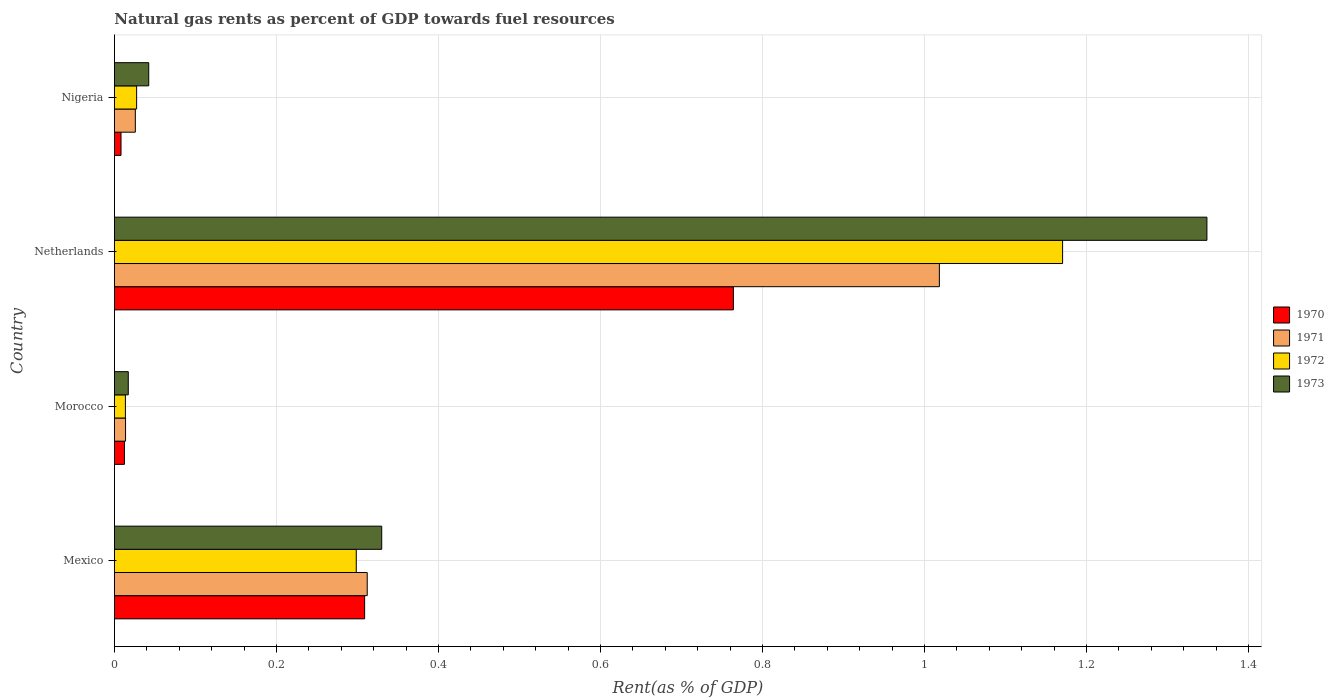Are the number of bars per tick equal to the number of legend labels?
Give a very brief answer. Yes. Are the number of bars on each tick of the Y-axis equal?
Keep it short and to the point. Yes. What is the label of the 3rd group of bars from the top?
Make the answer very short. Morocco. What is the matural gas rent in 1973 in Netherlands?
Provide a succinct answer. 1.35. Across all countries, what is the maximum matural gas rent in 1972?
Offer a very short reply. 1.17. Across all countries, what is the minimum matural gas rent in 1971?
Your answer should be very brief. 0.01. In which country was the matural gas rent in 1973 maximum?
Your answer should be very brief. Netherlands. In which country was the matural gas rent in 1972 minimum?
Offer a terse response. Morocco. What is the total matural gas rent in 1972 in the graph?
Ensure brevity in your answer.  1.51. What is the difference between the matural gas rent in 1970 in Netherlands and that in Nigeria?
Keep it short and to the point. 0.76. What is the difference between the matural gas rent in 1973 in Nigeria and the matural gas rent in 1970 in Mexico?
Your response must be concise. -0.27. What is the average matural gas rent in 1970 per country?
Provide a short and direct response. 0.27. What is the difference between the matural gas rent in 1972 and matural gas rent in 1971 in Mexico?
Ensure brevity in your answer.  -0.01. What is the ratio of the matural gas rent in 1970 in Morocco to that in Nigeria?
Keep it short and to the point. 1.52. Is the matural gas rent in 1973 in Morocco less than that in Nigeria?
Your response must be concise. Yes. What is the difference between the highest and the second highest matural gas rent in 1972?
Keep it short and to the point. 0.87. What is the difference between the highest and the lowest matural gas rent in 1970?
Give a very brief answer. 0.76. In how many countries, is the matural gas rent in 1972 greater than the average matural gas rent in 1972 taken over all countries?
Give a very brief answer. 1. Is it the case that in every country, the sum of the matural gas rent in 1973 and matural gas rent in 1970 is greater than the sum of matural gas rent in 1971 and matural gas rent in 1972?
Your answer should be very brief. No. What does the 3rd bar from the top in Nigeria represents?
Offer a terse response. 1971. Are all the bars in the graph horizontal?
Your response must be concise. Yes. How many countries are there in the graph?
Your response must be concise. 4. Where does the legend appear in the graph?
Your answer should be very brief. Center right. What is the title of the graph?
Your answer should be very brief. Natural gas rents as percent of GDP towards fuel resources. What is the label or title of the X-axis?
Your answer should be compact. Rent(as % of GDP). What is the label or title of the Y-axis?
Offer a very short reply. Country. What is the Rent(as % of GDP) of 1970 in Mexico?
Offer a terse response. 0.31. What is the Rent(as % of GDP) in 1971 in Mexico?
Keep it short and to the point. 0.31. What is the Rent(as % of GDP) of 1972 in Mexico?
Make the answer very short. 0.3. What is the Rent(as % of GDP) of 1973 in Mexico?
Ensure brevity in your answer.  0.33. What is the Rent(as % of GDP) in 1970 in Morocco?
Offer a terse response. 0.01. What is the Rent(as % of GDP) of 1971 in Morocco?
Offer a very short reply. 0.01. What is the Rent(as % of GDP) in 1972 in Morocco?
Your answer should be compact. 0.01. What is the Rent(as % of GDP) of 1973 in Morocco?
Offer a terse response. 0.02. What is the Rent(as % of GDP) in 1970 in Netherlands?
Your response must be concise. 0.76. What is the Rent(as % of GDP) in 1971 in Netherlands?
Provide a short and direct response. 1.02. What is the Rent(as % of GDP) of 1972 in Netherlands?
Offer a very short reply. 1.17. What is the Rent(as % of GDP) of 1973 in Netherlands?
Make the answer very short. 1.35. What is the Rent(as % of GDP) in 1970 in Nigeria?
Make the answer very short. 0.01. What is the Rent(as % of GDP) of 1971 in Nigeria?
Offer a terse response. 0.03. What is the Rent(as % of GDP) in 1972 in Nigeria?
Your answer should be very brief. 0.03. What is the Rent(as % of GDP) in 1973 in Nigeria?
Give a very brief answer. 0.04. Across all countries, what is the maximum Rent(as % of GDP) in 1970?
Provide a short and direct response. 0.76. Across all countries, what is the maximum Rent(as % of GDP) of 1971?
Your response must be concise. 1.02. Across all countries, what is the maximum Rent(as % of GDP) of 1972?
Your answer should be compact. 1.17. Across all countries, what is the maximum Rent(as % of GDP) of 1973?
Your answer should be compact. 1.35. Across all countries, what is the minimum Rent(as % of GDP) in 1970?
Your answer should be very brief. 0.01. Across all countries, what is the minimum Rent(as % of GDP) in 1971?
Provide a succinct answer. 0.01. Across all countries, what is the minimum Rent(as % of GDP) of 1972?
Your response must be concise. 0.01. Across all countries, what is the minimum Rent(as % of GDP) of 1973?
Give a very brief answer. 0.02. What is the total Rent(as % of GDP) of 1970 in the graph?
Give a very brief answer. 1.09. What is the total Rent(as % of GDP) of 1971 in the graph?
Give a very brief answer. 1.37. What is the total Rent(as % of GDP) in 1972 in the graph?
Provide a succinct answer. 1.51. What is the total Rent(as % of GDP) in 1973 in the graph?
Your answer should be compact. 1.74. What is the difference between the Rent(as % of GDP) in 1970 in Mexico and that in Morocco?
Provide a succinct answer. 0.3. What is the difference between the Rent(as % of GDP) of 1971 in Mexico and that in Morocco?
Make the answer very short. 0.3. What is the difference between the Rent(as % of GDP) in 1972 in Mexico and that in Morocco?
Provide a short and direct response. 0.28. What is the difference between the Rent(as % of GDP) in 1973 in Mexico and that in Morocco?
Provide a succinct answer. 0.31. What is the difference between the Rent(as % of GDP) in 1970 in Mexico and that in Netherlands?
Your response must be concise. -0.46. What is the difference between the Rent(as % of GDP) of 1971 in Mexico and that in Netherlands?
Your response must be concise. -0.71. What is the difference between the Rent(as % of GDP) of 1972 in Mexico and that in Netherlands?
Your response must be concise. -0.87. What is the difference between the Rent(as % of GDP) in 1973 in Mexico and that in Netherlands?
Your answer should be compact. -1.02. What is the difference between the Rent(as % of GDP) of 1970 in Mexico and that in Nigeria?
Keep it short and to the point. 0.3. What is the difference between the Rent(as % of GDP) of 1971 in Mexico and that in Nigeria?
Offer a terse response. 0.29. What is the difference between the Rent(as % of GDP) of 1972 in Mexico and that in Nigeria?
Your answer should be compact. 0.27. What is the difference between the Rent(as % of GDP) in 1973 in Mexico and that in Nigeria?
Your answer should be very brief. 0.29. What is the difference between the Rent(as % of GDP) in 1970 in Morocco and that in Netherlands?
Provide a short and direct response. -0.75. What is the difference between the Rent(as % of GDP) of 1971 in Morocco and that in Netherlands?
Keep it short and to the point. -1. What is the difference between the Rent(as % of GDP) in 1972 in Morocco and that in Netherlands?
Your answer should be very brief. -1.16. What is the difference between the Rent(as % of GDP) in 1973 in Morocco and that in Netherlands?
Provide a succinct answer. -1.33. What is the difference between the Rent(as % of GDP) in 1970 in Morocco and that in Nigeria?
Offer a very short reply. 0. What is the difference between the Rent(as % of GDP) of 1971 in Morocco and that in Nigeria?
Offer a terse response. -0.01. What is the difference between the Rent(as % of GDP) of 1972 in Morocco and that in Nigeria?
Your answer should be very brief. -0.01. What is the difference between the Rent(as % of GDP) of 1973 in Morocco and that in Nigeria?
Offer a very short reply. -0.03. What is the difference between the Rent(as % of GDP) of 1970 in Netherlands and that in Nigeria?
Your answer should be compact. 0.76. What is the difference between the Rent(as % of GDP) of 1972 in Netherlands and that in Nigeria?
Offer a terse response. 1.14. What is the difference between the Rent(as % of GDP) of 1973 in Netherlands and that in Nigeria?
Keep it short and to the point. 1.31. What is the difference between the Rent(as % of GDP) in 1970 in Mexico and the Rent(as % of GDP) in 1971 in Morocco?
Provide a succinct answer. 0.3. What is the difference between the Rent(as % of GDP) of 1970 in Mexico and the Rent(as % of GDP) of 1972 in Morocco?
Your answer should be very brief. 0.3. What is the difference between the Rent(as % of GDP) in 1970 in Mexico and the Rent(as % of GDP) in 1973 in Morocco?
Offer a very short reply. 0.29. What is the difference between the Rent(as % of GDP) of 1971 in Mexico and the Rent(as % of GDP) of 1972 in Morocco?
Make the answer very short. 0.3. What is the difference between the Rent(as % of GDP) of 1971 in Mexico and the Rent(as % of GDP) of 1973 in Morocco?
Give a very brief answer. 0.29. What is the difference between the Rent(as % of GDP) of 1972 in Mexico and the Rent(as % of GDP) of 1973 in Morocco?
Your answer should be compact. 0.28. What is the difference between the Rent(as % of GDP) in 1970 in Mexico and the Rent(as % of GDP) in 1971 in Netherlands?
Offer a terse response. -0.71. What is the difference between the Rent(as % of GDP) of 1970 in Mexico and the Rent(as % of GDP) of 1972 in Netherlands?
Make the answer very short. -0.86. What is the difference between the Rent(as % of GDP) in 1970 in Mexico and the Rent(as % of GDP) in 1973 in Netherlands?
Offer a very short reply. -1.04. What is the difference between the Rent(as % of GDP) in 1971 in Mexico and the Rent(as % of GDP) in 1972 in Netherlands?
Offer a very short reply. -0.86. What is the difference between the Rent(as % of GDP) in 1971 in Mexico and the Rent(as % of GDP) in 1973 in Netherlands?
Keep it short and to the point. -1.04. What is the difference between the Rent(as % of GDP) in 1972 in Mexico and the Rent(as % of GDP) in 1973 in Netherlands?
Give a very brief answer. -1.05. What is the difference between the Rent(as % of GDP) of 1970 in Mexico and the Rent(as % of GDP) of 1971 in Nigeria?
Offer a very short reply. 0.28. What is the difference between the Rent(as % of GDP) in 1970 in Mexico and the Rent(as % of GDP) in 1972 in Nigeria?
Make the answer very short. 0.28. What is the difference between the Rent(as % of GDP) of 1970 in Mexico and the Rent(as % of GDP) of 1973 in Nigeria?
Offer a very short reply. 0.27. What is the difference between the Rent(as % of GDP) in 1971 in Mexico and the Rent(as % of GDP) in 1972 in Nigeria?
Give a very brief answer. 0.28. What is the difference between the Rent(as % of GDP) in 1971 in Mexico and the Rent(as % of GDP) in 1973 in Nigeria?
Give a very brief answer. 0.27. What is the difference between the Rent(as % of GDP) of 1972 in Mexico and the Rent(as % of GDP) of 1973 in Nigeria?
Provide a short and direct response. 0.26. What is the difference between the Rent(as % of GDP) in 1970 in Morocco and the Rent(as % of GDP) in 1971 in Netherlands?
Provide a succinct answer. -1.01. What is the difference between the Rent(as % of GDP) of 1970 in Morocco and the Rent(as % of GDP) of 1972 in Netherlands?
Offer a terse response. -1.16. What is the difference between the Rent(as % of GDP) in 1970 in Morocco and the Rent(as % of GDP) in 1973 in Netherlands?
Offer a very short reply. -1.34. What is the difference between the Rent(as % of GDP) in 1971 in Morocco and the Rent(as % of GDP) in 1972 in Netherlands?
Provide a succinct answer. -1.16. What is the difference between the Rent(as % of GDP) in 1971 in Morocco and the Rent(as % of GDP) in 1973 in Netherlands?
Offer a very short reply. -1.33. What is the difference between the Rent(as % of GDP) in 1972 in Morocco and the Rent(as % of GDP) in 1973 in Netherlands?
Offer a very short reply. -1.34. What is the difference between the Rent(as % of GDP) of 1970 in Morocco and the Rent(as % of GDP) of 1971 in Nigeria?
Your answer should be very brief. -0.01. What is the difference between the Rent(as % of GDP) in 1970 in Morocco and the Rent(as % of GDP) in 1972 in Nigeria?
Offer a very short reply. -0.02. What is the difference between the Rent(as % of GDP) in 1970 in Morocco and the Rent(as % of GDP) in 1973 in Nigeria?
Your response must be concise. -0.03. What is the difference between the Rent(as % of GDP) of 1971 in Morocco and the Rent(as % of GDP) of 1972 in Nigeria?
Provide a short and direct response. -0.01. What is the difference between the Rent(as % of GDP) of 1971 in Morocco and the Rent(as % of GDP) of 1973 in Nigeria?
Provide a short and direct response. -0.03. What is the difference between the Rent(as % of GDP) in 1972 in Morocco and the Rent(as % of GDP) in 1973 in Nigeria?
Offer a terse response. -0.03. What is the difference between the Rent(as % of GDP) in 1970 in Netherlands and the Rent(as % of GDP) in 1971 in Nigeria?
Make the answer very short. 0.74. What is the difference between the Rent(as % of GDP) of 1970 in Netherlands and the Rent(as % of GDP) of 1972 in Nigeria?
Offer a terse response. 0.74. What is the difference between the Rent(as % of GDP) in 1970 in Netherlands and the Rent(as % of GDP) in 1973 in Nigeria?
Offer a very short reply. 0.72. What is the difference between the Rent(as % of GDP) of 1972 in Netherlands and the Rent(as % of GDP) of 1973 in Nigeria?
Provide a short and direct response. 1.13. What is the average Rent(as % of GDP) of 1970 per country?
Your answer should be very brief. 0.27. What is the average Rent(as % of GDP) in 1971 per country?
Ensure brevity in your answer.  0.34. What is the average Rent(as % of GDP) of 1972 per country?
Give a very brief answer. 0.38. What is the average Rent(as % of GDP) of 1973 per country?
Make the answer very short. 0.43. What is the difference between the Rent(as % of GDP) in 1970 and Rent(as % of GDP) in 1971 in Mexico?
Your answer should be very brief. -0. What is the difference between the Rent(as % of GDP) of 1970 and Rent(as % of GDP) of 1972 in Mexico?
Ensure brevity in your answer.  0.01. What is the difference between the Rent(as % of GDP) of 1970 and Rent(as % of GDP) of 1973 in Mexico?
Your response must be concise. -0.02. What is the difference between the Rent(as % of GDP) in 1971 and Rent(as % of GDP) in 1972 in Mexico?
Offer a terse response. 0.01. What is the difference between the Rent(as % of GDP) of 1971 and Rent(as % of GDP) of 1973 in Mexico?
Offer a very short reply. -0.02. What is the difference between the Rent(as % of GDP) in 1972 and Rent(as % of GDP) in 1973 in Mexico?
Offer a very short reply. -0.03. What is the difference between the Rent(as % of GDP) in 1970 and Rent(as % of GDP) in 1971 in Morocco?
Ensure brevity in your answer.  -0. What is the difference between the Rent(as % of GDP) of 1970 and Rent(as % of GDP) of 1972 in Morocco?
Ensure brevity in your answer.  -0. What is the difference between the Rent(as % of GDP) of 1970 and Rent(as % of GDP) of 1973 in Morocco?
Your answer should be compact. -0. What is the difference between the Rent(as % of GDP) of 1971 and Rent(as % of GDP) of 1972 in Morocco?
Keep it short and to the point. 0. What is the difference between the Rent(as % of GDP) in 1971 and Rent(as % of GDP) in 1973 in Morocco?
Provide a succinct answer. -0. What is the difference between the Rent(as % of GDP) of 1972 and Rent(as % of GDP) of 1973 in Morocco?
Ensure brevity in your answer.  -0. What is the difference between the Rent(as % of GDP) of 1970 and Rent(as % of GDP) of 1971 in Netherlands?
Give a very brief answer. -0.25. What is the difference between the Rent(as % of GDP) of 1970 and Rent(as % of GDP) of 1972 in Netherlands?
Give a very brief answer. -0.41. What is the difference between the Rent(as % of GDP) in 1970 and Rent(as % of GDP) in 1973 in Netherlands?
Provide a short and direct response. -0.58. What is the difference between the Rent(as % of GDP) in 1971 and Rent(as % of GDP) in 1972 in Netherlands?
Offer a very short reply. -0.15. What is the difference between the Rent(as % of GDP) in 1971 and Rent(as % of GDP) in 1973 in Netherlands?
Offer a very short reply. -0.33. What is the difference between the Rent(as % of GDP) of 1972 and Rent(as % of GDP) of 1973 in Netherlands?
Provide a short and direct response. -0.18. What is the difference between the Rent(as % of GDP) of 1970 and Rent(as % of GDP) of 1971 in Nigeria?
Ensure brevity in your answer.  -0.02. What is the difference between the Rent(as % of GDP) of 1970 and Rent(as % of GDP) of 1972 in Nigeria?
Give a very brief answer. -0.02. What is the difference between the Rent(as % of GDP) in 1970 and Rent(as % of GDP) in 1973 in Nigeria?
Offer a terse response. -0.03. What is the difference between the Rent(as % of GDP) in 1971 and Rent(as % of GDP) in 1972 in Nigeria?
Your answer should be compact. -0. What is the difference between the Rent(as % of GDP) in 1971 and Rent(as % of GDP) in 1973 in Nigeria?
Your answer should be compact. -0.02. What is the difference between the Rent(as % of GDP) in 1972 and Rent(as % of GDP) in 1973 in Nigeria?
Offer a terse response. -0.01. What is the ratio of the Rent(as % of GDP) of 1970 in Mexico to that in Morocco?
Give a very brief answer. 25. What is the ratio of the Rent(as % of GDP) in 1971 in Mexico to that in Morocco?
Make the answer very short. 22.74. What is the ratio of the Rent(as % of GDP) in 1972 in Mexico to that in Morocco?
Keep it short and to the point. 22.04. What is the ratio of the Rent(as % of GDP) of 1973 in Mexico to that in Morocco?
Your answer should be compact. 19.3. What is the ratio of the Rent(as % of GDP) of 1970 in Mexico to that in Netherlands?
Keep it short and to the point. 0.4. What is the ratio of the Rent(as % of GDP) of 1971 in Mexico to that in Netherlands?
Ensure brevity in your answer.  0.31. What is the ratio of the Rent(as % of GDP) in 1972 in Mexico to that in Netherlands?
Offer a terse response. 0.26. What is the ratio of the Rent(as % of GDP) of 1973 in Mexico to that in Netherlands?
Offer a terse response. 0.24. What is the ratio of the Rent(as % of GDP) in 1970 in Mexico to that in Nigeria?
Your response must be concise. 37.97. What is the ratio of the Rent(as % of GDP) in 1971 in Mexico to that in Nigeria?
Ensure brevity in your answer.  12.1. What is the ratio of the Rent(as % of GDP) of 1972 in Mexico to that in Nigeria?
Provide a succinct answer. 10.89. What is the ratio of the Rent(as % of GDP) of 1973 in Mexico to that in Nigeria?
Make the answer very short. 7.79. What is the ratio of the Rent(as % of GDP) in 1970 in Morocco to that in Netherlands?
Provide a short and direct response. 0.02. What is the ratio of the Rent(as % of GDP) in 1971 in Morocco to that in Netherlands?
Your response must be concise. 0.01. What is the ratio of the Rent(as % of GDP) in 1972 in Morocco to that in Netherlands?
Your answer should be compact. 0.01. What is the ratio of the Rent(as % of GDP) in 1973 in Morocco to that in Netherlands?
Give a very brief answer. 0.01. What is the ratio of the Rent(as % of GDP) in 1970 in Morocco to that in Nigeria?
Ensure brevity in your answer.  1.52. What is the ratio of the Rent(as % of GDP) of 1971 in Morocco to that in Nigeria?
Your answer should be compact. 0.53. What is the ratio of the Rent(as % of GDP) in 1972 in Morocco to that in Nigeria?
Keep it short and to the point. 0.49. What is the ratio of the Rent(as % of GDP) in 1973 in Morocco to that in Nigeria?
Make the answer very short. 0.4. What is the ratio of the Rent(as % of GDP) in 1970 in Netherlands to that in Nigeria?
Your answer should be very brief. 93.94. What is the ratio of the Rent(as % of GDP) in 1971 in Netherlands to that in Nigeria?
Give a very brief answer. 39.48. What is the ratio of the Rent(as % of GDP) in 1972 in Netherlands to that in Nigeria?
Give a very brief answer. 42.7. What is the ratio of the Rent(as % of GDP) in 1973 in Netherlands to that in Nigeria?
Give a very brief answer. 31.84. What is the difference between the highest and the second highest Rent(as % of GDP) of 1970?
Your answer should be compact. 0.46. What is the difference between the highest and the second highest Rent(as % of GDP) of 1971?
Offer a terse response. 0.71. What is the difference between the highest and the second highest Rent(as % of GDP) in 1972?
Your answer should be very brief. 0.87. What is the difference between the highest and the second highest Rent(as % of GDP) of 1973?
Provide a short and direct response. 1.02. What is the difference between the highest and the lowest Rent(as % of GDP) of 1970?
Your response must be concise. 0.76. What is the difference between the highest and the lowest Rent(as % of GDP) of 1971?
Your answer should be very brief. 1. What is the difference between the highest and the lowest Rent(as % of GDP) in 1972?
Keep it short and to the point. 1.16. What is the difference between the highest and the lowest Rent(as % of GDP) in 1973?
Your response must be concise. 1.33. 